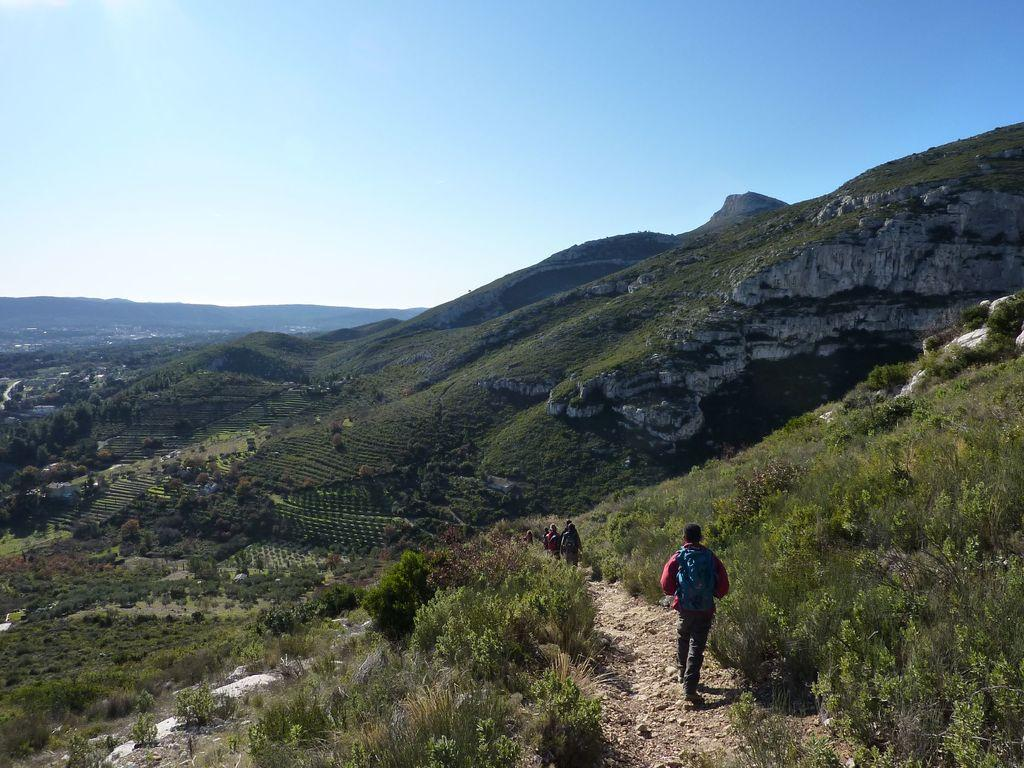What are the people in the image doing? The people in the image are walking. How would you describe the road they are walking on? The road they are walking on is uneven. What can be seen in front of the people as they walk? There are small plants and greenery in front of the people. How many planes can be seen flying over the town in the image? There is no town or planes visible in the image; it features people walking on an uneven road with small plants and greenery in front of them. What type of hole is present in the image? There is no hole present in the image. 